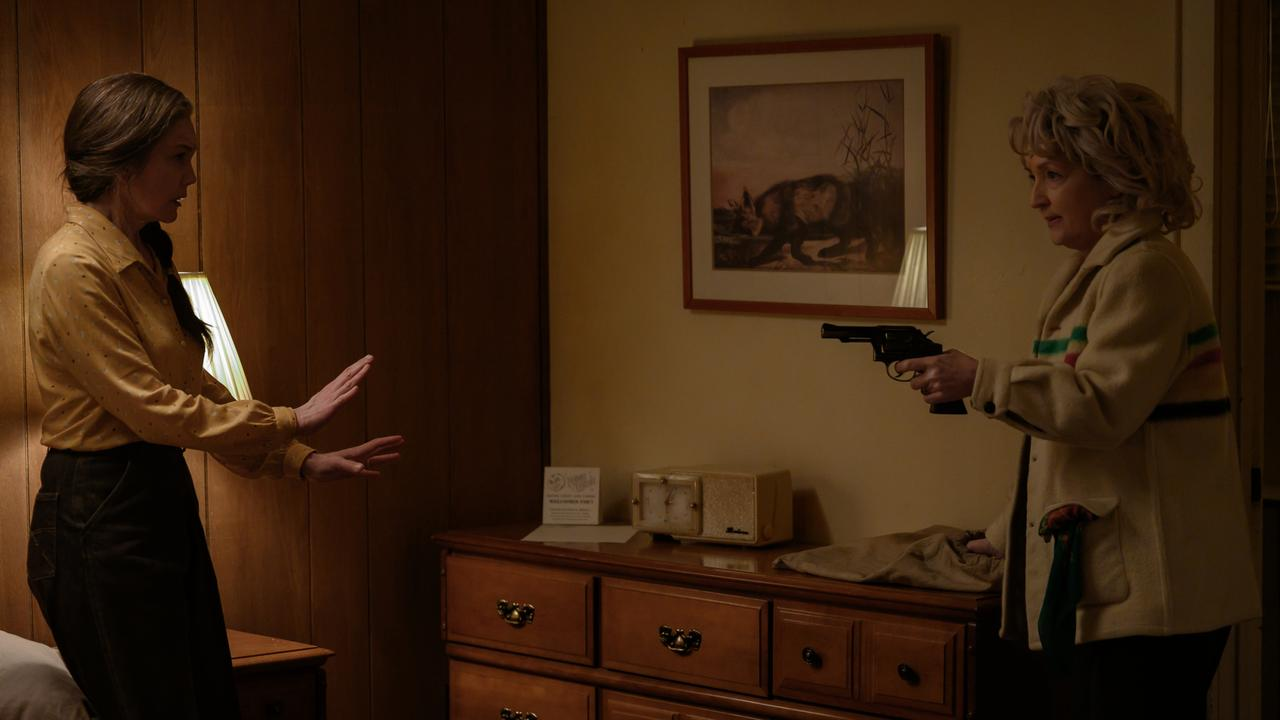Write a detailed description of the given image. In this dramatic scene, two women are engaged in a tense confrontation within a rustic bedroom setting. The woman on the left, wearing a yellow blouse and black pants, appears distressed and is clearly pleading, with her hands outstretched in a gesture of supplication. She faces another woman, who, holding a gun, is dressed in a cream-colored jacket that features a distinctive rainbow stripe on the sleeve, adding a stark contrast to the intense situation.

The background of the room is characterized by its warm, wooden paneling, which enhances the room's cozy yet tense atmosphere. A dresser against the wall is topped with a series of small items, and above it hangs a framed picture depicting a wolf in a wild landscape. The overall mood conveys high stakes and palpable tension, suggestive of a pivotal moment in a film or television show. 